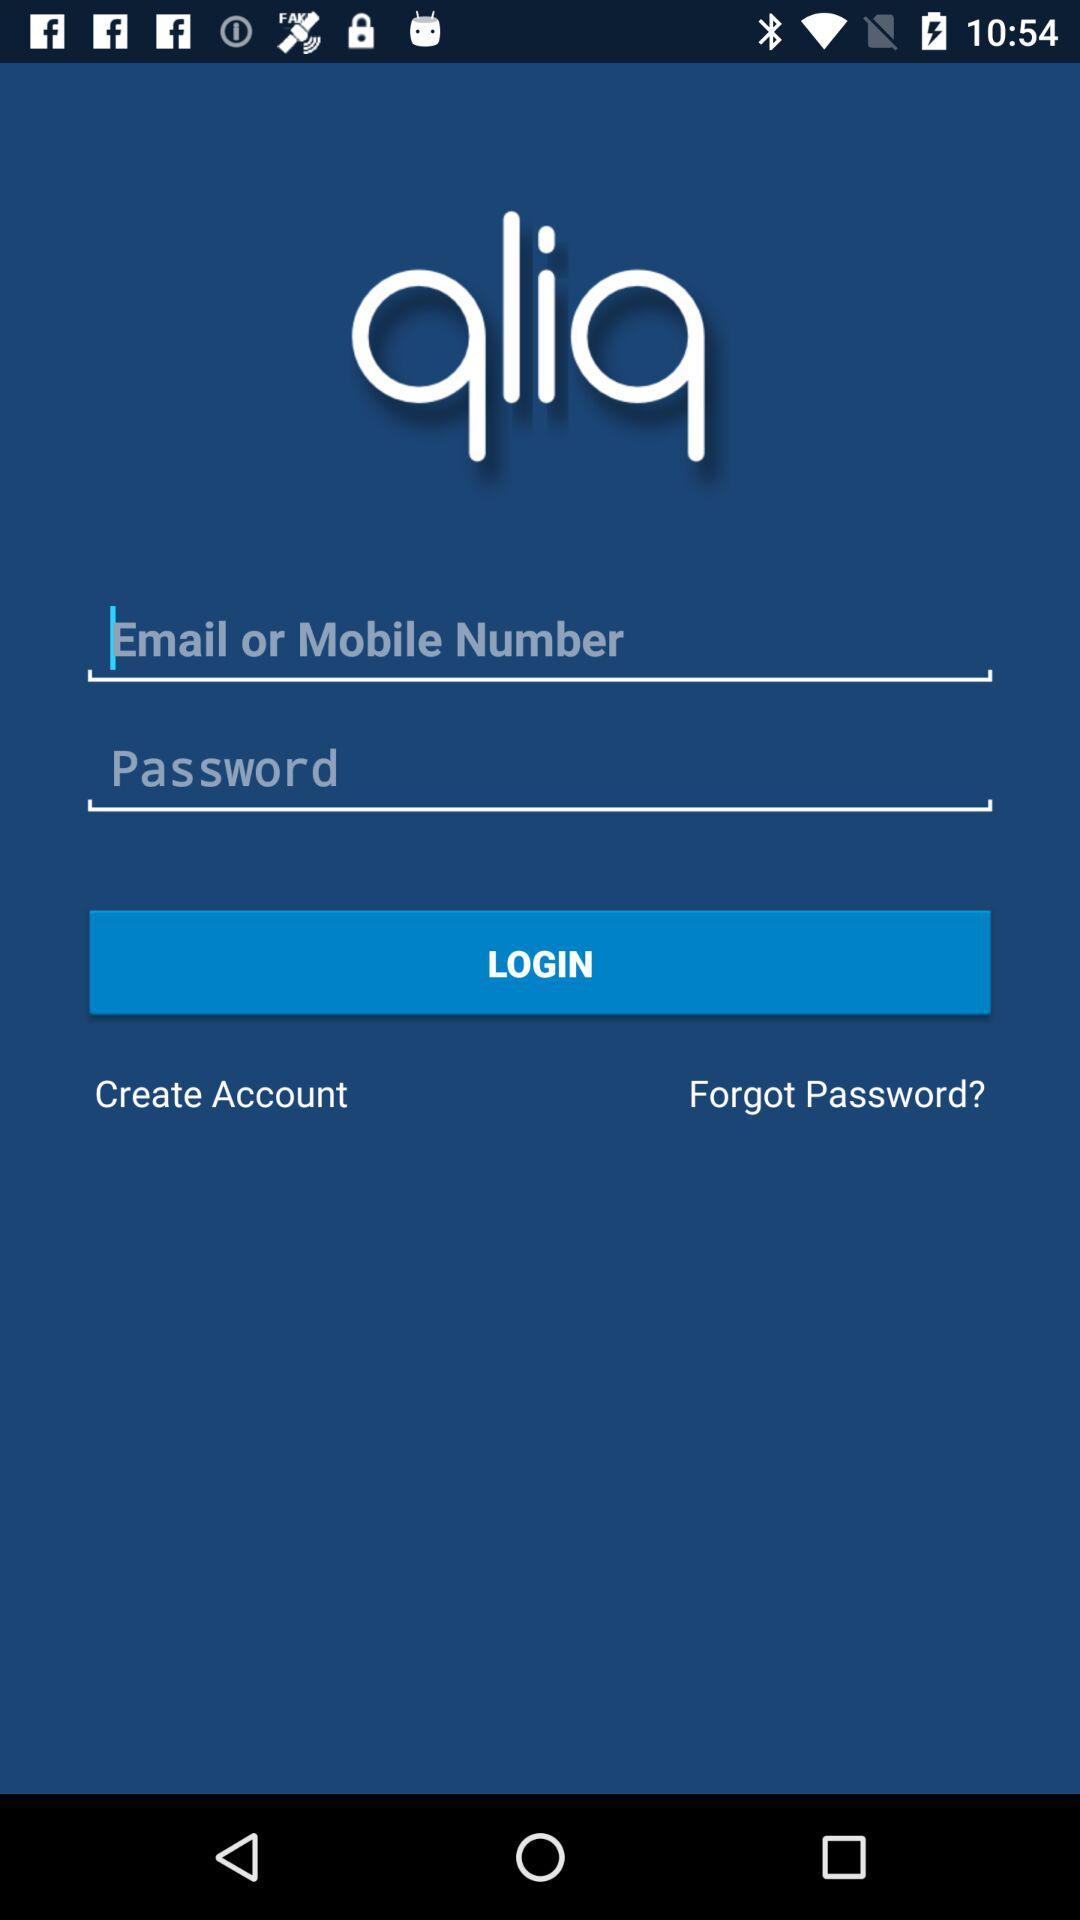What is the application name? The application name is "qliq". 